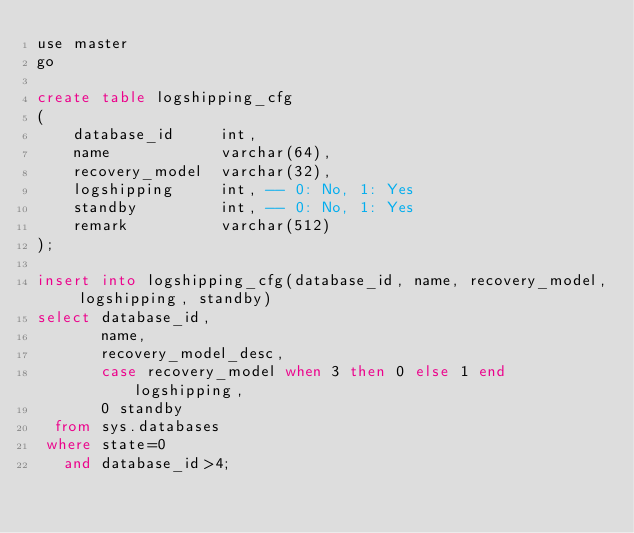Convert code to text. <code><loc_0><loc_0><loc_500><loc_500><_SQL_>use master
go

create table logshipping_cfg
(
    database_id     int,
    name            varchar(64),
    recovery_model  varchar(32),
    logshipping     int, -- 0: No, 1: Yes
    standby         int, -- 0: No, 1: Yes
    remark          varchar(512)
);

insert into logshipping_cfg(database_id, name, recovery_model, logshipping, standby)
select database_id,
       name,
       recovery_model_desc,
       case recovery_model when 3 then 0 else 1 end logshipping,
       0 standby
  from sys.databases
 where state=0
   and database_id>4;

</code> 